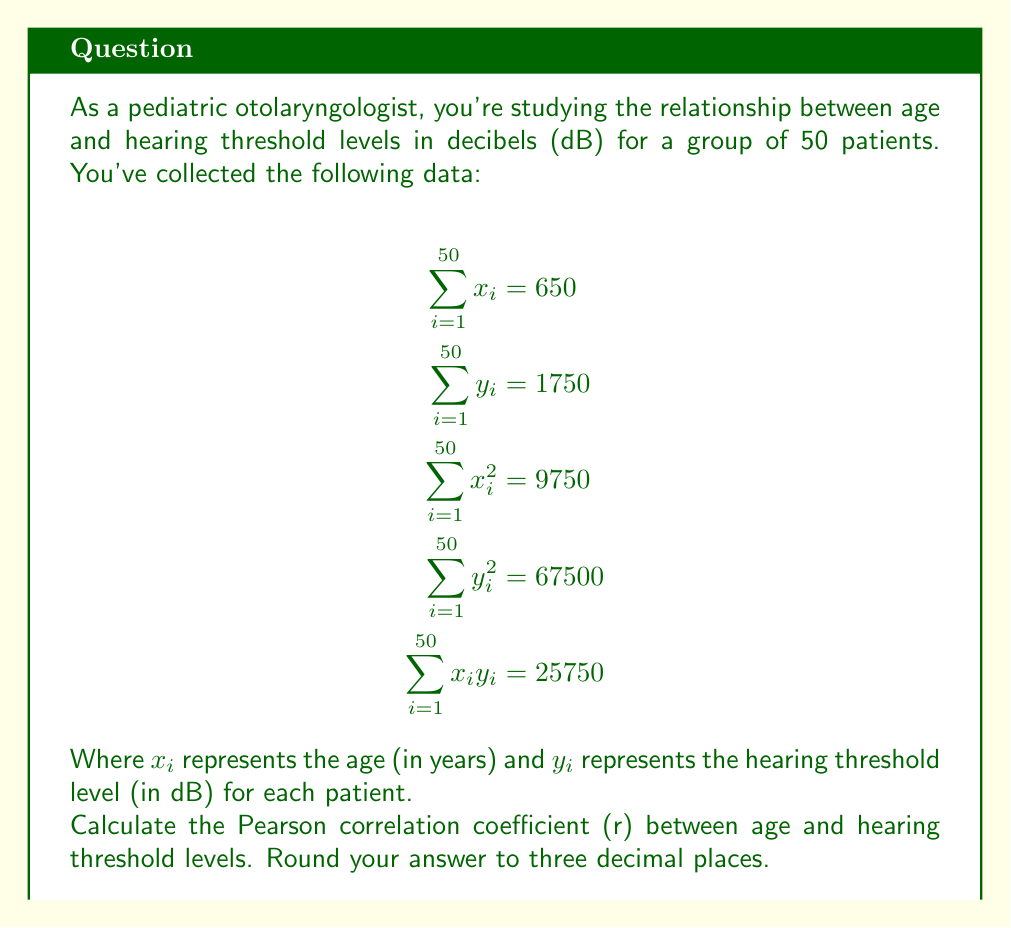Help me with this question. To calculate the Pearson correlation coefficient (r), we'll use the formula:

$$r = \frac{n\sum x_iy_i - (\sum x_i)(\sum y_i)}{\sqrt{[n\sum x_i^2 - (\sum x_i)^2][n\sum y_i^2 - (\sum y_i)^2]}}$$

Where n is the number of patients (50 in this case).

Step 1: Calculate $n\sum x_iy_i$
$50 * 25750 = 1287500$

Step 2: Calculate $(\sum x_i)(\sum y_i)$
$650 * 1750 = 1137500$

Step 3: Calculate the numerator
$1287500 - 1137500 = 150000$

Step 4: Calculate $n\sum x_i^2$
$50 * 9750 = 487500$

Step 5: Calculate $(\sum x_i)^2$
$650^2 = 422500$

Step 6: Calculate $n\sum y_i^2$
$50 * 67500 = 3375000$

Step 7: Calculate $(\sum y_i)^2$
$1750^2 = 3062500$

Step 8: Calculate the denominator
$\sqrt{(487500 - 422500)(3375000 - 3062500)}$
$= \sqrt{65000 * 312500}$
$= \sqrt{20312500000}$
$= 142520.19$

Step 9: Calculate r
$r = \frac{150000}{142520.19} = 1.0524$

Step 10: Round to three decimal places
$r = 1.052$
Answer: $r = 1.052$ 